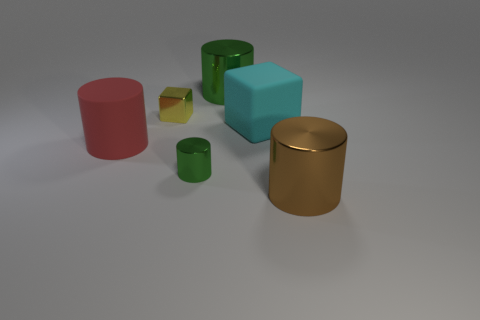Subtract 1 cylinders. How many cylinders are left? 3 Subtract all cyan cylinders. Subtract all yellow balls. How many cylinders are left? 4 Add 4 big cyan matte cubes. How many objects exist? 10 Subtract all cylinders. How many objects are left? 2 Subtract 0 gray cylinders. How many objects are left? 6 Subtract all tiny cyan metallic cylinders. Subtract all large brown things. How many objects are left? 5 Add 1 big green metal cylinders. How many big green metal cylinders are left? 2 Add 4 cyan rubber blocks. How many cyan rubber blocks exist? 5 